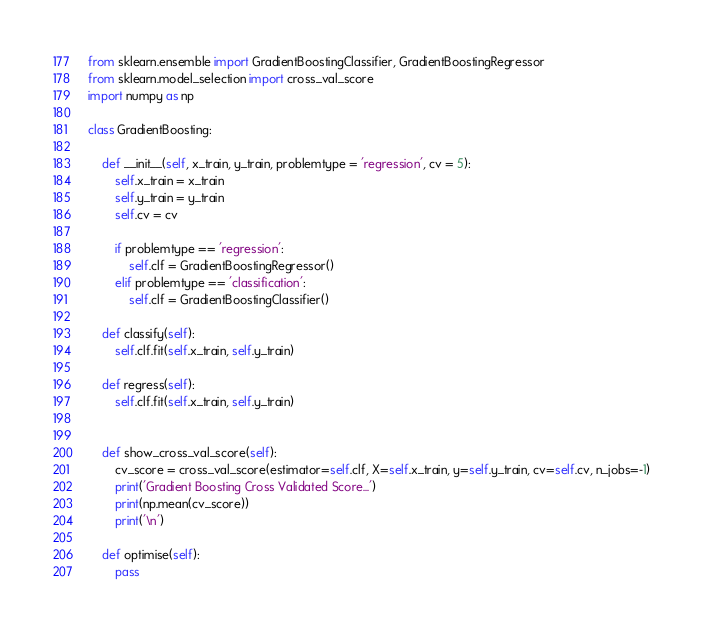<code> <loc_0><loc_0><loc_500><loc_500><_Python_>from sklearn.ensemble import GradientBoostingClassifier, GradientBoostingRegressor
from sklearn.model_selection import cross_val_score
import numpy as np

class GradientBoosting:

    def __init__(self, x_train, y_train, problemtype = 'regression', cv = 5):
        self.x_train = x_train
        self.y_train = y_train
        self.cv = cv

        if problemtype == 'regression':
            self.clf = GradientBoostingRegressor()
        elif problemtype == 'classification':
            self.clf = GradientBoostingClassifier()

    def classify(self):
        self.clf.fit(self.x_train, self.y_train)

    def regress(self):
        self.clf.fit(self.x_train, self.y_train)


    def show_cross_val_score(self):
        cv_score = cross_val_score(estimator=self.clf, X=self.x_train, y=self.y_train, cv=self.cv, n_jobs=-1)
        print('Gradient Boosting Cross Validated Score...')
        print(np.mean(cv_score))
        print('\n')

    def optimise(self):
        pass
</code> 